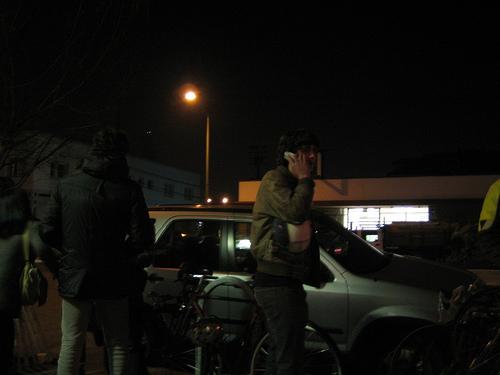What color is the car?
Concise answer only. Silver. Which person is on their phone?
Be succinct. Man. Was the photo taken at night?
Write a very short answer. Yes. 